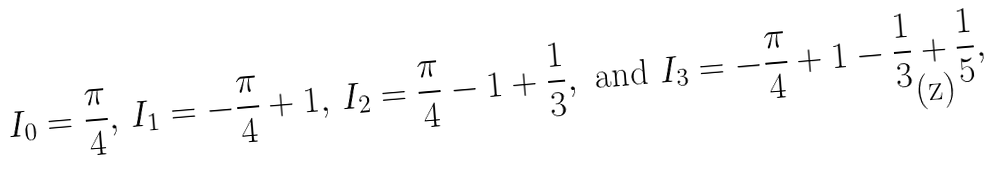<formula> <loc_0><loc_0><loc_500><loc_500>I _ { 0 } = \frac { \pi } { 4 } , \, I _ { 1 } = - \frac { \pi } { 4 } + 1 , \, I _ { 2 } = \frac { \pi } { 4 } - 1 + \frac { 1 } { 3 } , \text { and } I _ { 3 } = - \frac { \pi } { 4 } + 1 - \frac { 1 } { 3 } + \frac { 1 } { 5 } ,</formula> 